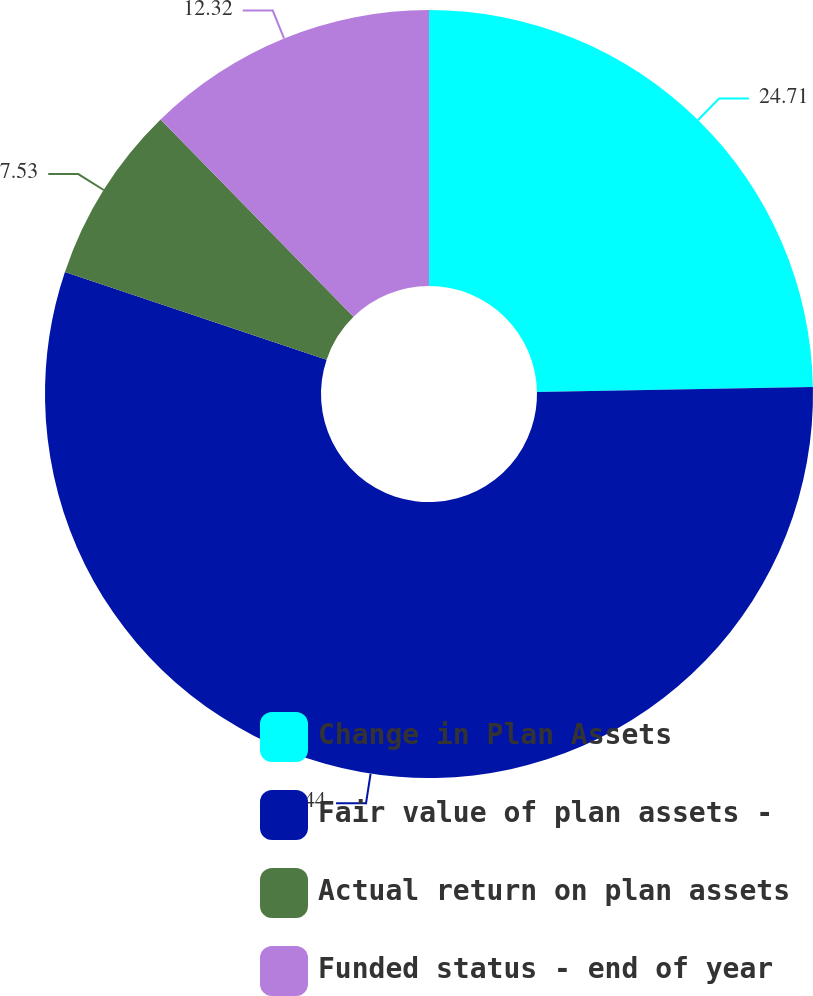<chart> <loc_0><loc_0><loc_500><loc_500><pie_chart><fcel>Change in Plan Assets<fcel>Fair value of plan assets -<fcel>Actual return on plan assets<fcel>Funded status - end of year<nl><fcel>24.71%<fcel>55.44%<fcel>7.53%<fcel>12.32%<nl></chart> 